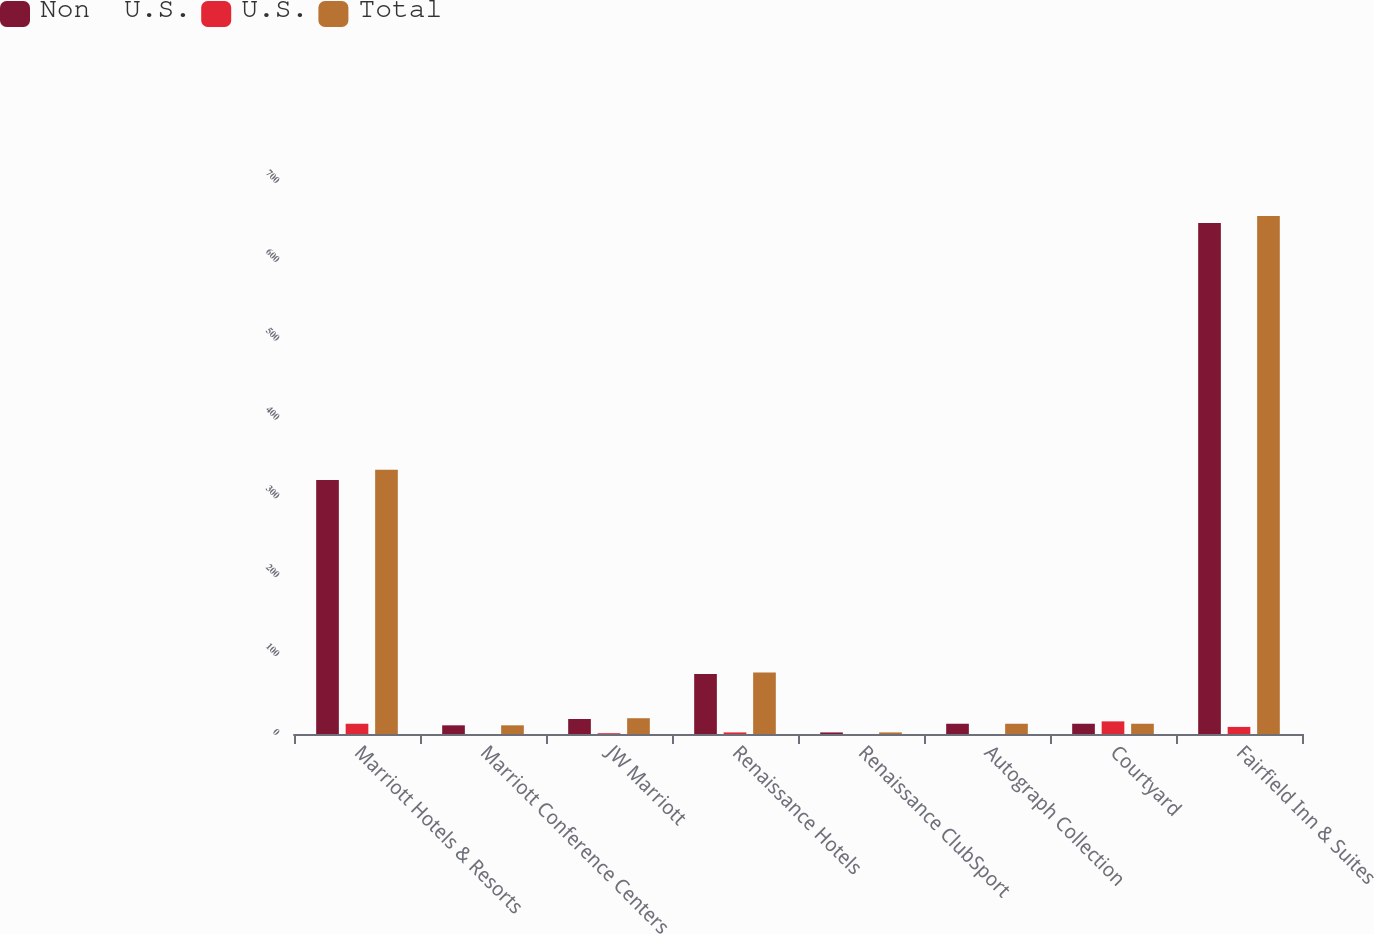Convert chart to OTSL. <chart><loc_0><loc_0><loc_500><loc_500><stacked_bar_chart><ecel><fcel>Marriott Hotels & Resorts<fcel>Marriott Conference Centers<fcel>JW Marriott<fcel>Renaissance Hotels<fcel>Renaissance ClubSport<fcel>Autograph Collection<fcel>Courtyard<fcel>Fairfield Inn & Suites<nl><fcel>Non  U.S.<fcel>322<fcel>11<fcel>19<fcel>76<fcel>2<fcel>13<fcel>13<fcel>648<nl><fcel>U.S.<fcel>13<fcel>0<fcel>1<fcel>2<fcel>0<fcel>0<fcel>16<fcel>9<nl><fcel>Total<fcel>335<fcel>11<fcel>20<fcel>78<fcel>2<fcel>13<fcel>13<fcel>657<nl></chart> 